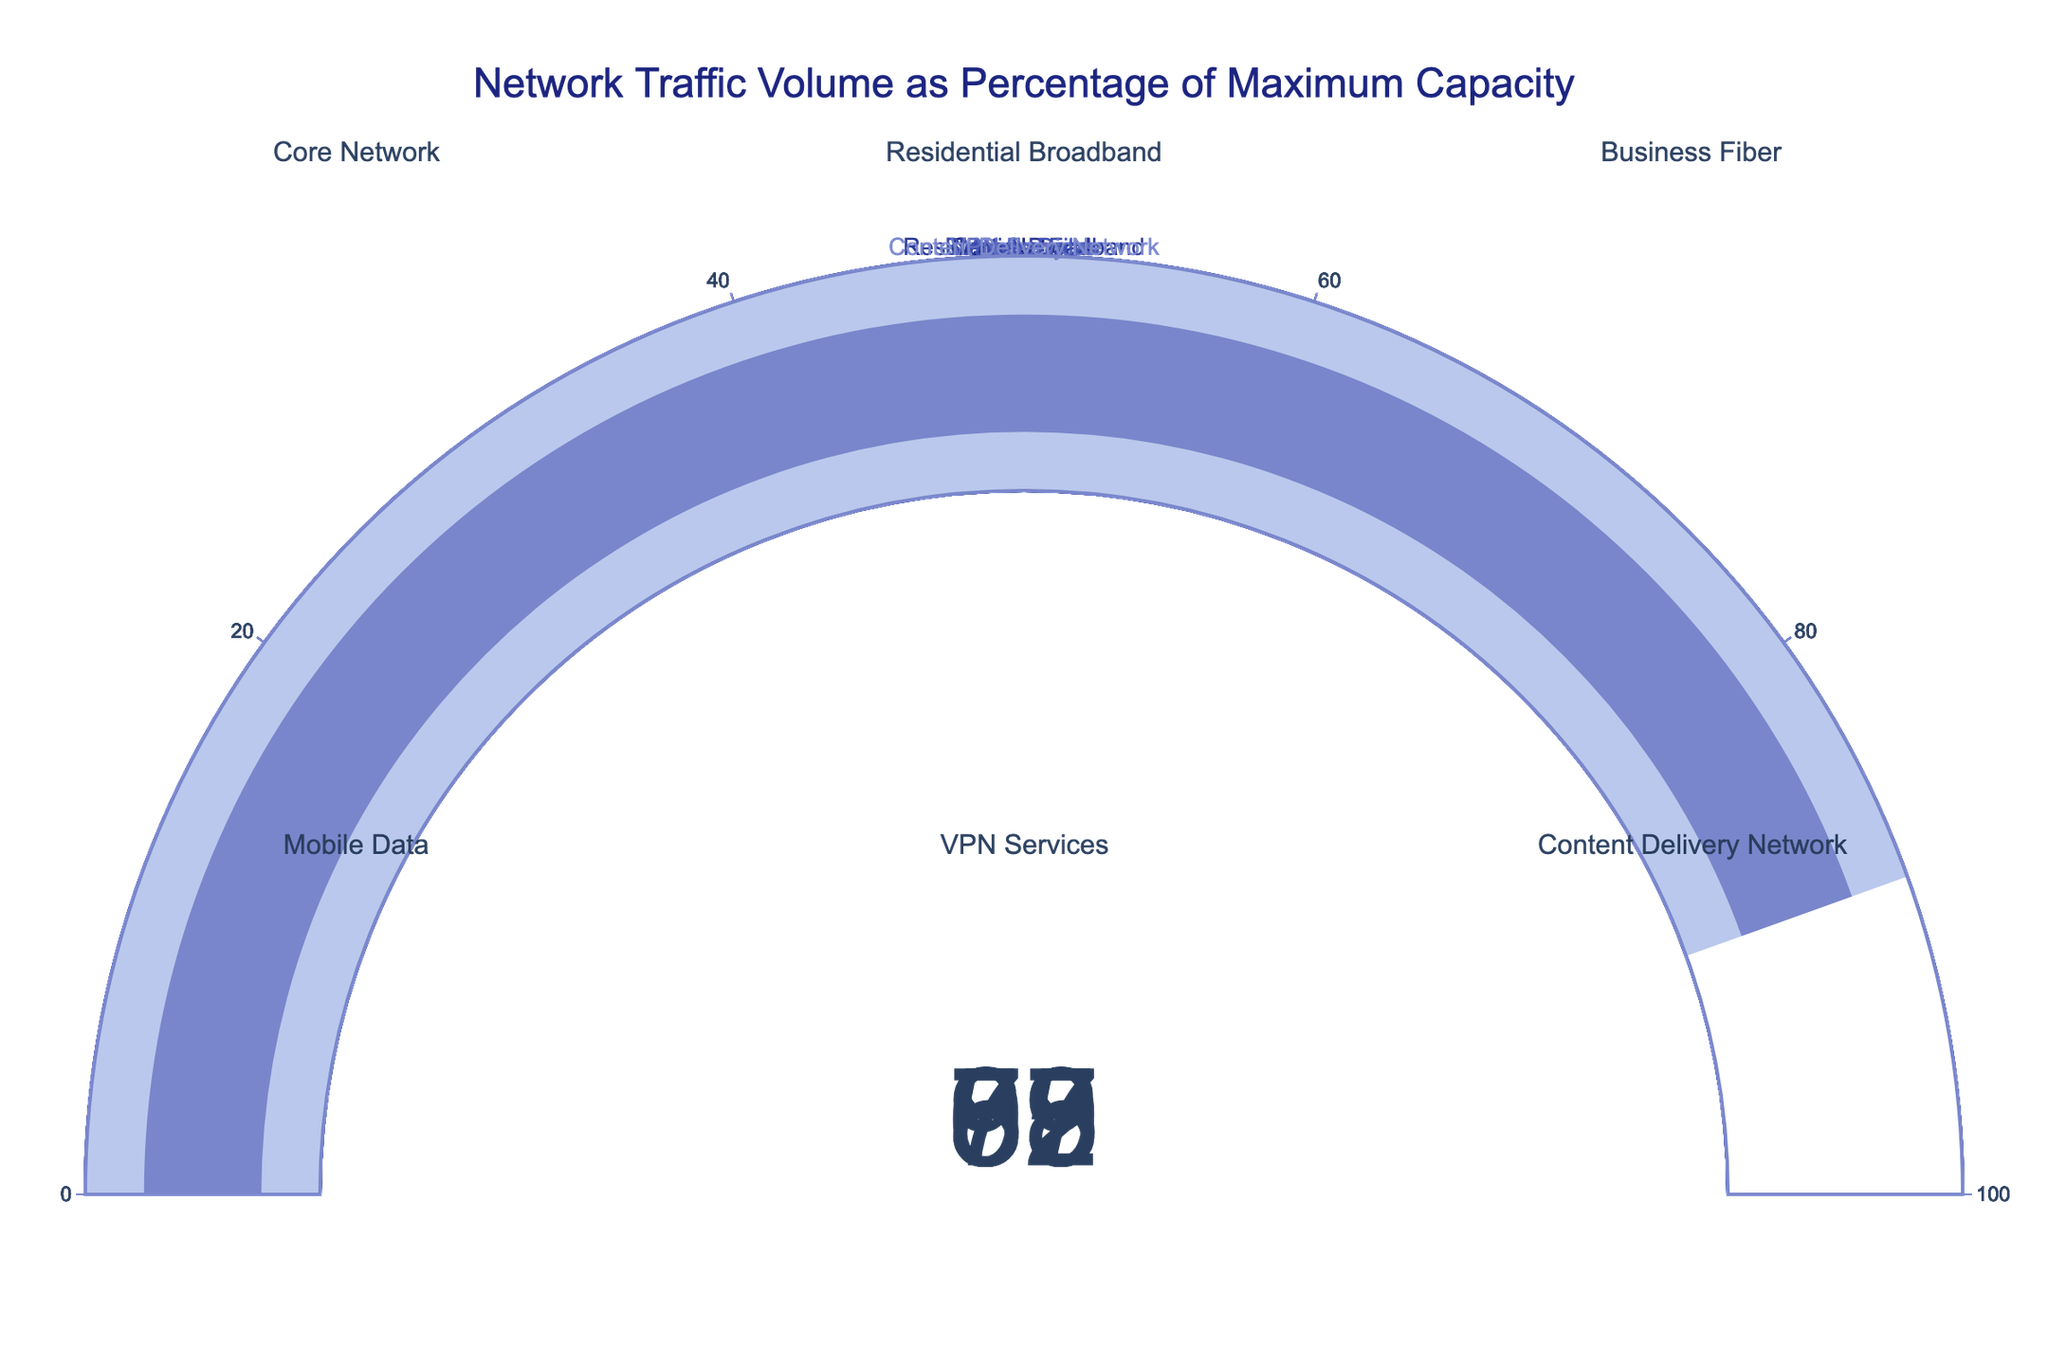What's the highest traffic percentage among the networks? The highest value on the gauge charts represents the maximum traffic percentage. In this case, the Business Fiber network has the highest traffic percentage of 92%.
Answer: 92% Which network has the lowest traffic percentage? To find the lowest traffic percentage, look for the smallest value on the gauge charts. The VPN Services network has the lowest at 57%.
Answer: 57% What is the average traffic percentage across all networks? Add all the traffic percentages and divide by the number of networks: (78 + 65 + 92 + 83 + 57 + 89) / 6 = 464 / 6 = 77.33.
Answer: 77.33 How many networks have a traffic percentage above 80%? Count the number of networks with traffic percentages greater than 80%. Core Network (78), Business Fiber (92), Mobile Data (83), and Content Delivery Network (89) all qualify. This results in 4 networks.
Answer: 4 Which network is using the highest percentage of its capacity? Identify the network with the highest value on its gauge. Business Fiber, with 92%, is using the highest percentage of its capacity.
Answer: Business Fiber Compare the traffic percentages of Residential Broadband and Core Network. Which one is higher? Compare the two values: Residential Broadband is 65% and Core Network is 78%. Core Network has a higher traffic percentage.
Answer: Core Network What is the traffic percentage range across all networks? Subtract the lowest traffic percentage from the highest: 92% (Business Fiber) - 57% (VPN Services) = 35%.
Answer: 35% Is the Mobile Data network above or below 80% capacity? According to its gauge, Mobile Data has a traffic percentage of 83%, which is above 80%.
Answer: Above Which networks fall into the 70-90% traffic range? Check each gauge for values between 70% and 90%. Core Network (78%), Business Fiber (92%), Mobile Data (83%), and Content Delivery Network (89%) fit this range.
Answer: Core Network, Business Fiber, Mobile Data, Content Delivery Network Is any network at or near full capacity? If so, which one? Full capacity is 100%. Business Fiber, with 92%, is the closest to full capacity.
Answer: Business Fiber 